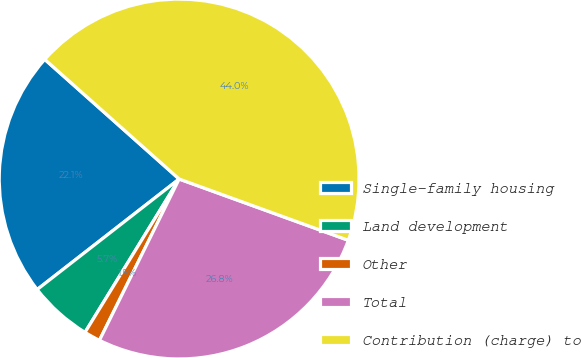Convert chart to OTSL. <chart><loc_0><loc_0><loc_500><loc_500><pie_chart><fcel>Single-family housing<fcel>Land development<fcel>Other<fcel>Total<fcel>Contribution (charge) to<nl><fcel>22.1%<fcel>5.71%<fcel>1.46%<fcel>26.77%<fcel>43.95%<nl></chart> 